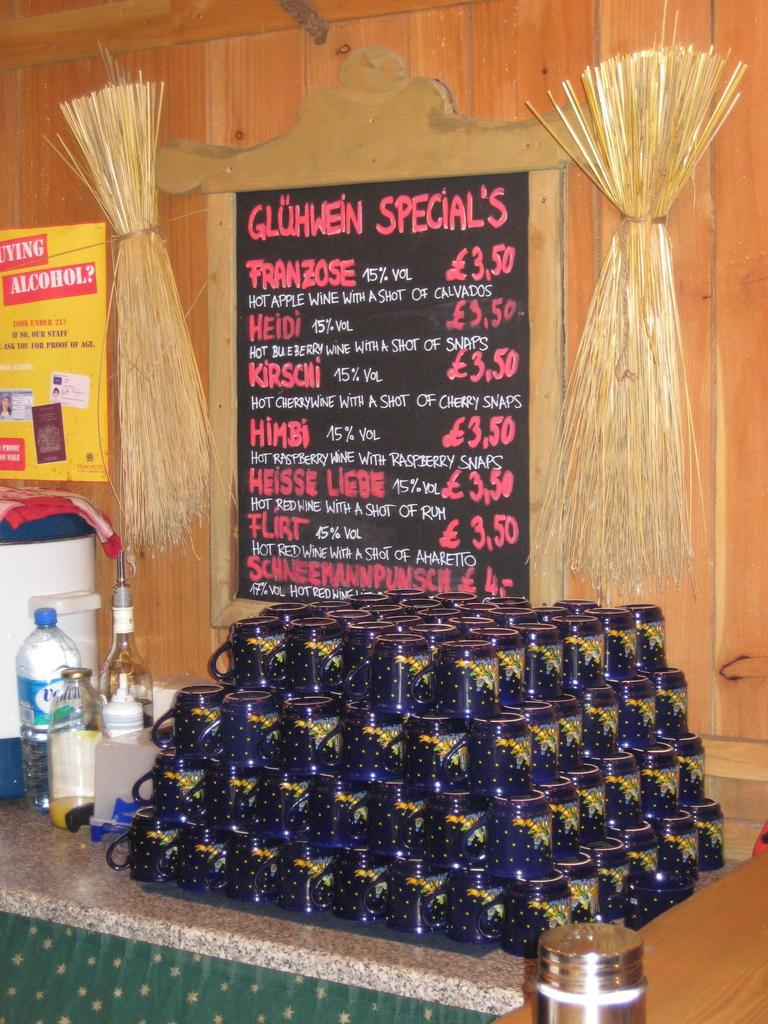Provide a one-sentence caption for the provided image. A stack of blue mugs in front of a sign advertising the day's specials. 